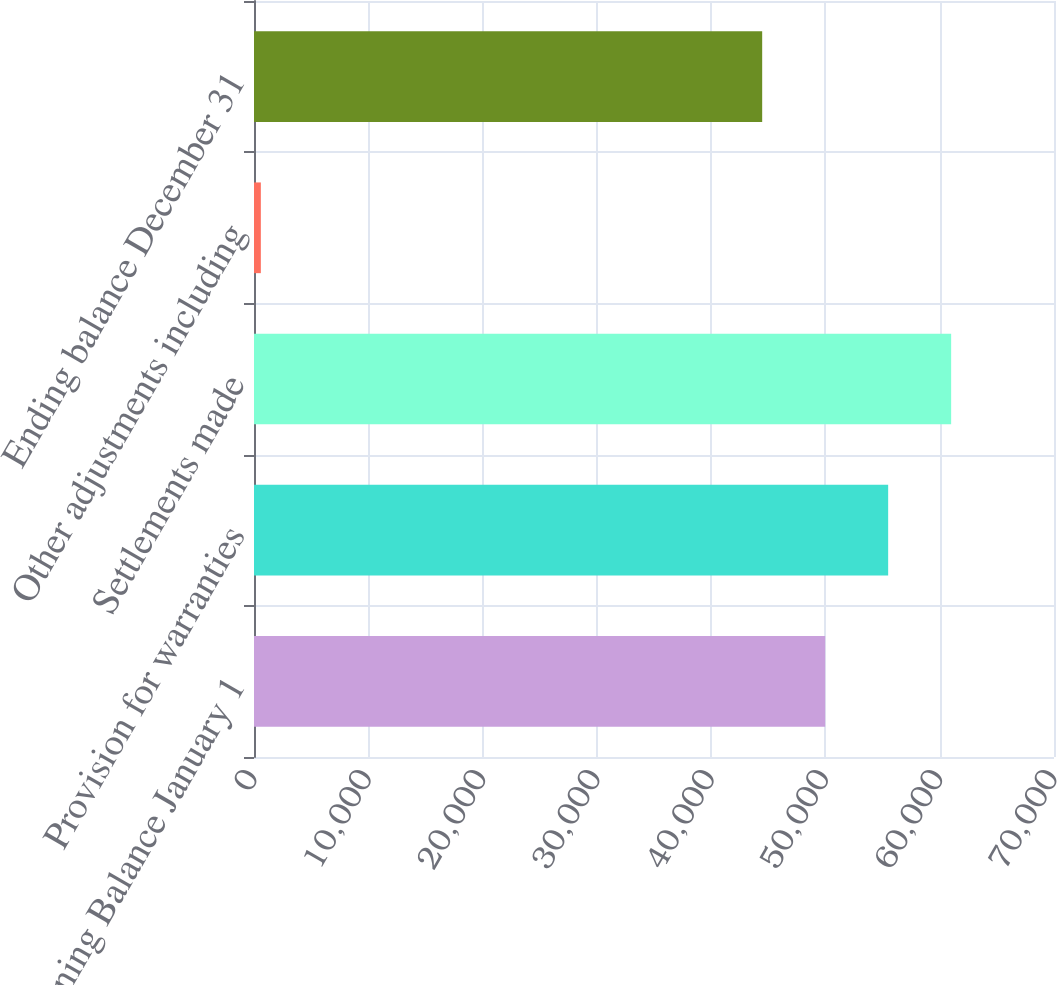Convert chart to OTSL. <chart><loc_0><loc_0><loc_500><loc_500><bar_chart><fcel>Beginning Balance January 1<fcel>Provision for warranties<fcel>Settlements made<fcel>Other adjustments including<fcel>Ending balance December 31<nl><fcel>49977.6<fcel>55489.2<fcel>61000.8<fcel>599<fcel>44466<nl></chart> 